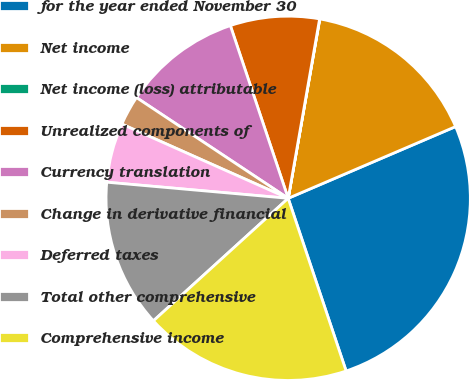Convert chart to OTSL. <chart><loc_0><loc_0><loc_500><loc_500><pie_chart><fcel>for the year ended November 30<fcel>Net income<fcel>Net income (loss) attributable<fcel>Unrealized components of<fcel>Currency translation<fcel>Change in derivative financial<fcel>Deferred taxes<fcel>Total other comprehensive<fcel>Comprehensive income<nl><fcel>26.29%<fcel>15.78%<fcel>0.02%<fcel>7.9%<fcel>10.53%<fcel>2.65%<fcel>5.27%<fcel>13.15%<fcel>18.41%<nl></chart> 